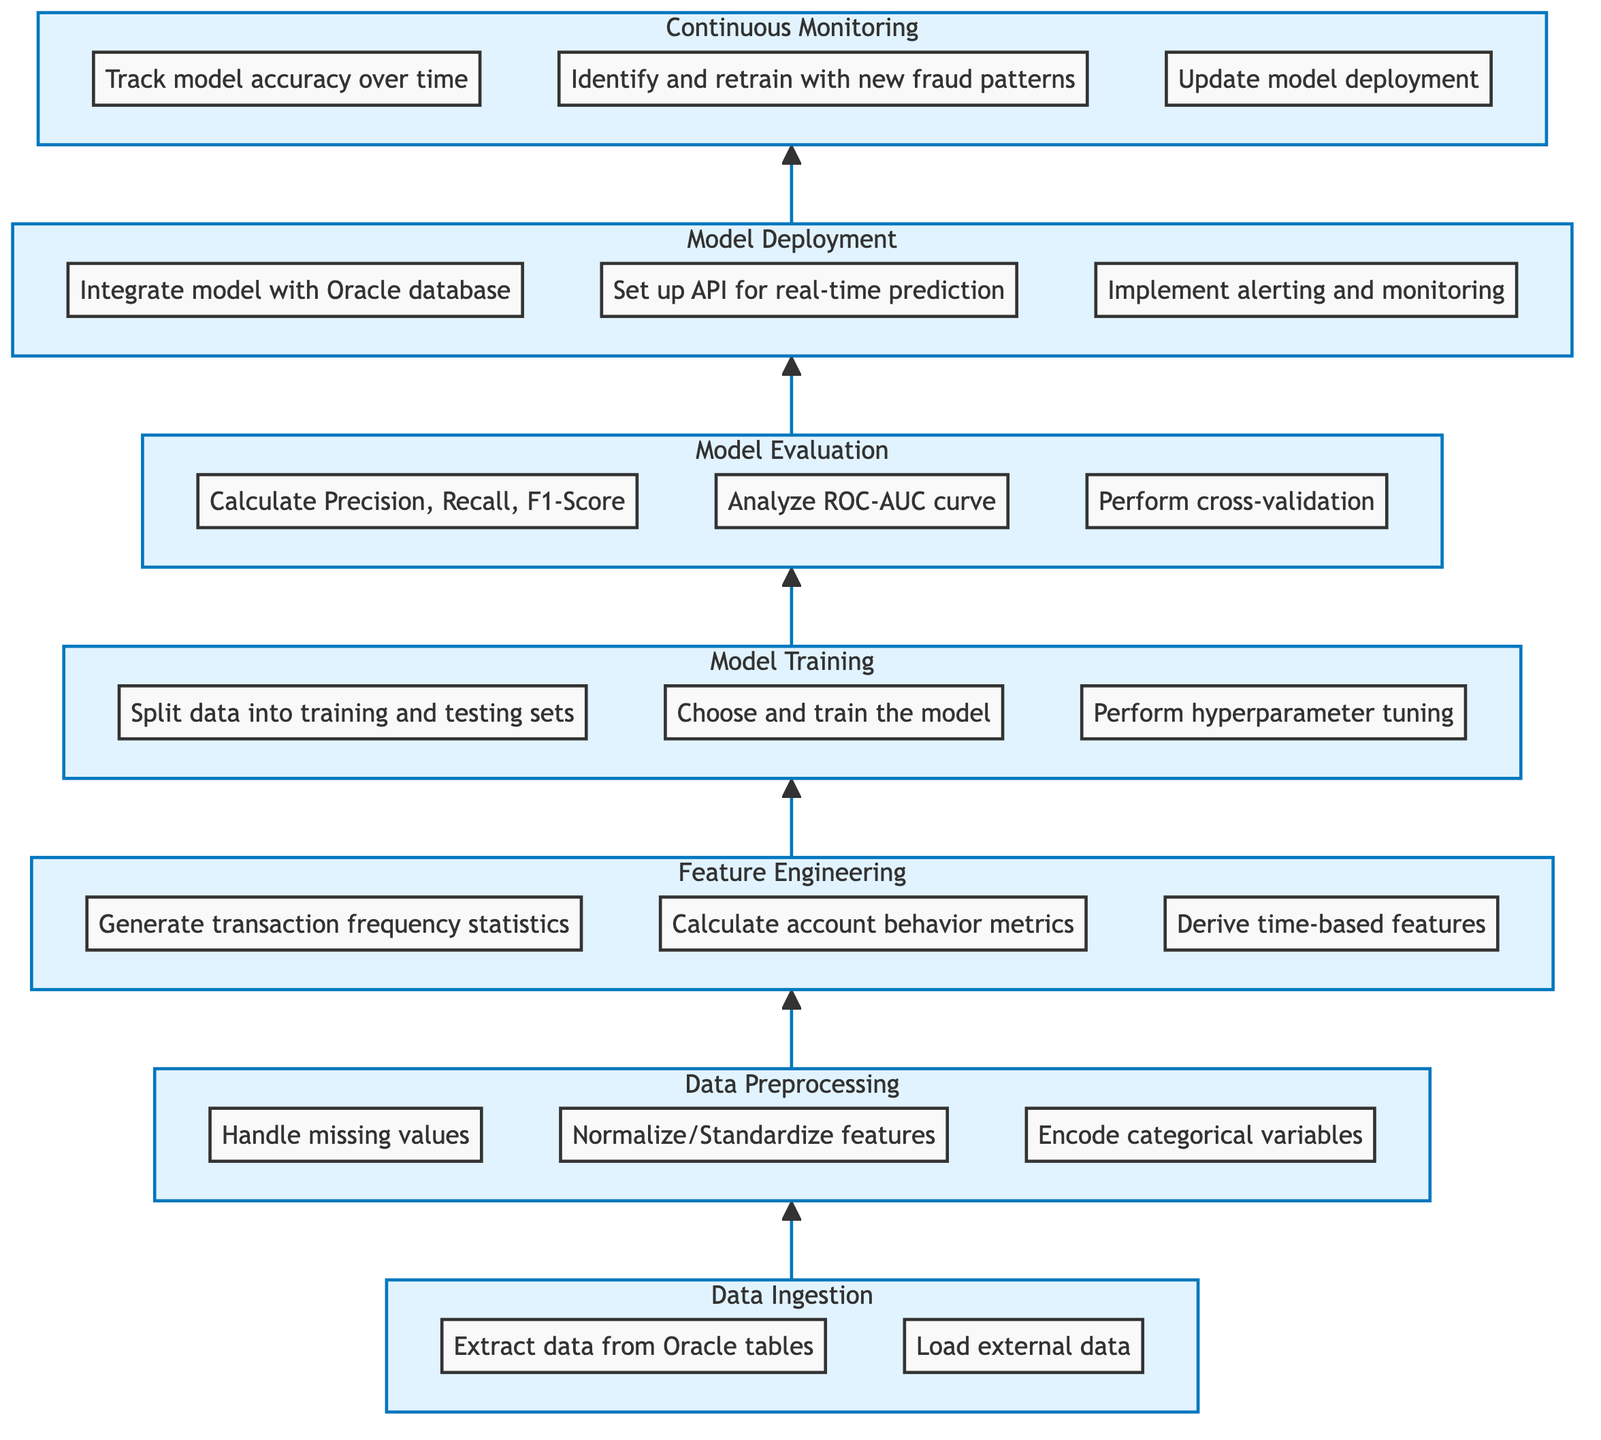What is the first step in the process? The first step in the process, indicated at the bottom of the flow chart, is "Data Ingestion," where the system starts collecting transaction data.
Answer: Data Ingestion How many sub-processes are in Data Preprocessing? In the "Data Preprocessing" step, there are three sub-processes: handle missing values, normalize/standardize features, and encode categorical variables.
Answer: Three What follows after Model Training? The process flows from "Model Training" directly to "Model Evaluation," indicating that evaluation happens immediately after training the model.
Answer: Model Evaluation What are the last two steps in the process? The last two steps, shown at the top of the flow chart, are "Model Deployment" followed by "Continuous Monitoring," indicating the final actions taken in establishing a fraud detection system.
Answer: Model Deployment, Continuous Monitoring Which step involves creating new features for fraud detection? The "Feature Engineering" phase involves creating new features relevant for fraud detection, making it a pivotal step between data preprocessing and model training.
Answer: Feature Engineering What metric is not evaluated in Model Evaluation? The "Model Evaluation" step does not mention metrics like Mean Absolute Error, indicating that it primarily focuses on Precision, Recall, F1-Score, and ROC-AUC curves instead.
Answer: Mean Absolute Error What is integrated with the Oracle database during Model Deployment? During the "Model Deployment" phase, the trained model is integrated with the Oracle database to enable real-time fraud detection capabilities.
Answer: Trained model How is the process monitored continuously? The "Continuous Monitoring" step tracks model accuracy over time, identifies new fraud patterns, and updates the model deployment as necessary to ensure ongoing effectiveness.
Answer: Track model accuracy over time What is the purpose of the hyperparameter tuning sub-process? Hyperparameter tuning, a crucial part of the "Model Training" step, is used to optimize the performance of the chosen machine learning model, enhancing its ability to detect fraudulent transactions.
Answer: Optimize performance 